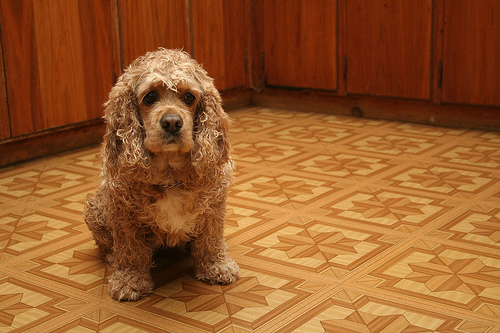<image>
Can you confirm if the dog is on the tile? Yes. Looking at the image, I can see the dog is positioned on top of the tile, with the tile providing support. Is the dog on the door? No. The dog is not positioned on the door. They may be near each other, but the dog is not supported by or resting on top of the door. 